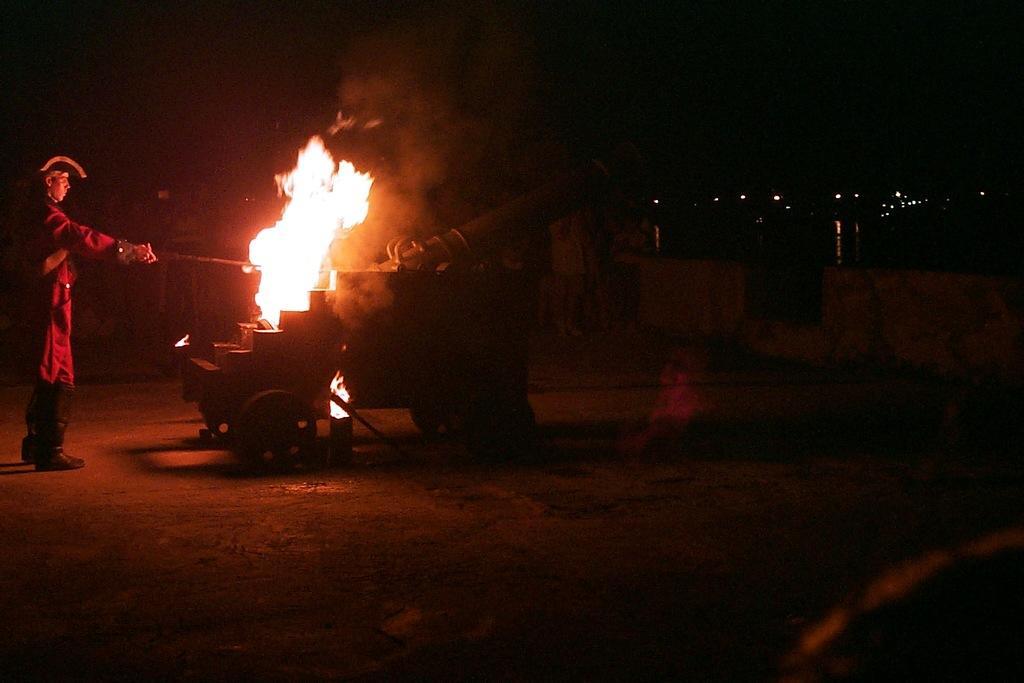Please provide a concise description of this image. In this image, on the left side, we can see a man wearing a hat and he is also holding a stick in his hand. In the middle of the image, we can see a war weapon. In the background, we can see few lights. At the top, we can see black color, at the bottom, we can see land. 